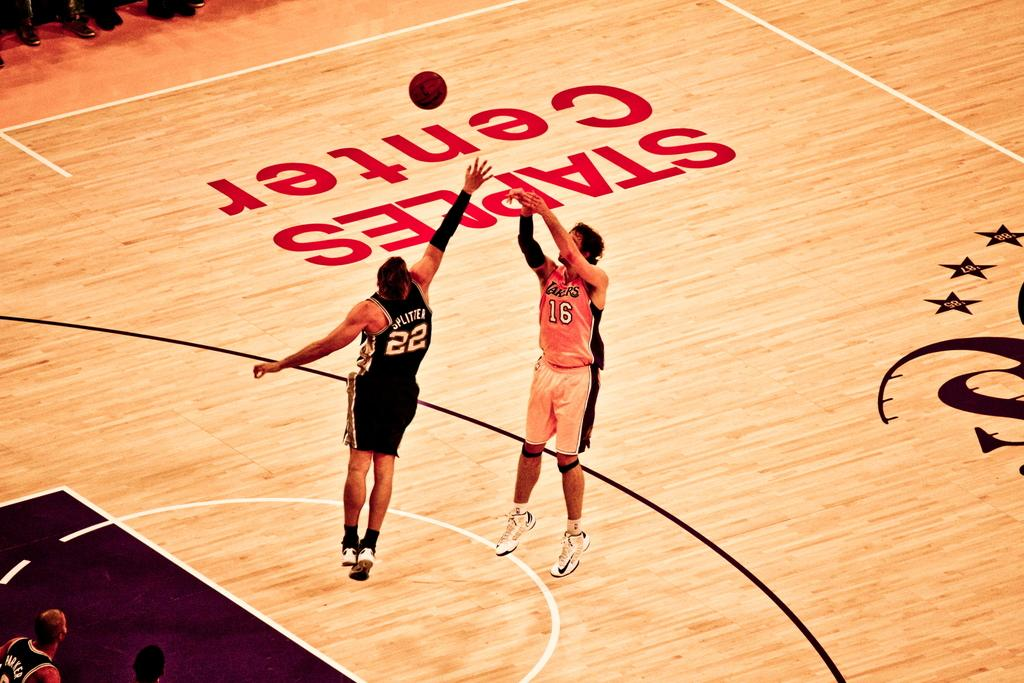What object can be seen in the image? There is a ball in the image. What are the two men doing in the image? The two men are in the air in the image. Are there any other people visible in the image? Yes, there are people on the ground in the image. What type of farm animals can be seen in the image? There are no farm animals present in the image. How many kittens are playing with the ball in the image? There are no kittens present in the image. 